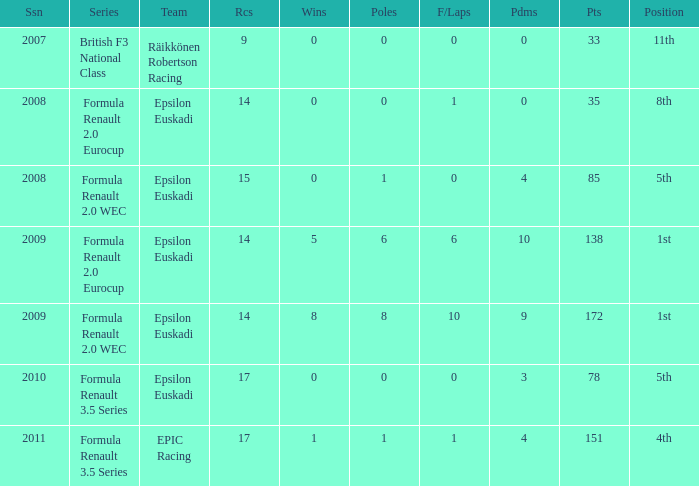What team was he on when he finished in 11th position? Räikkönen Robertson Racing. 